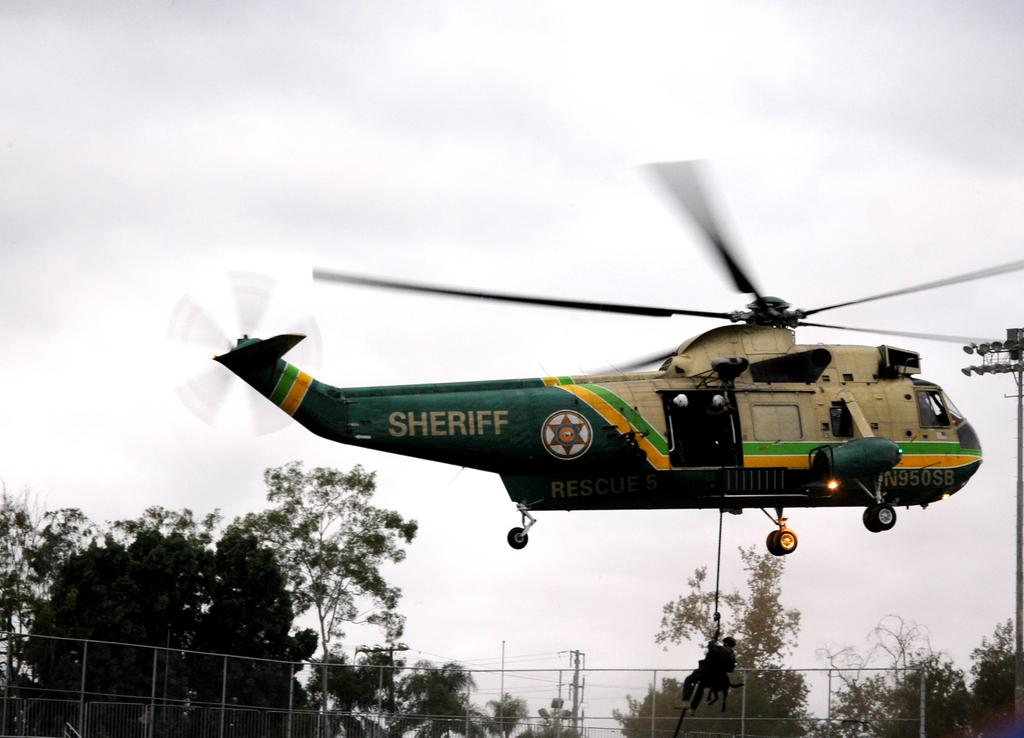<image>
Describe the image concisely. The sheriff's helicopter is flying to rescue people from a storm 